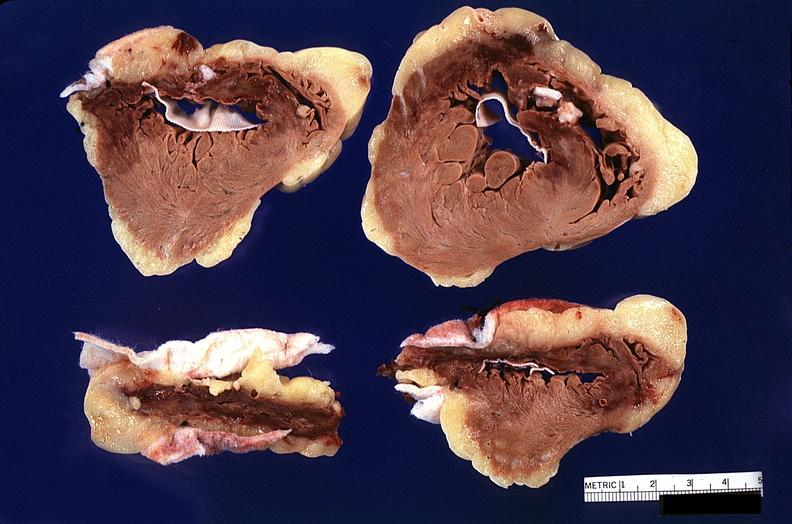s cardiovascular present?
Answer the question using a single word or phrase. Yes 